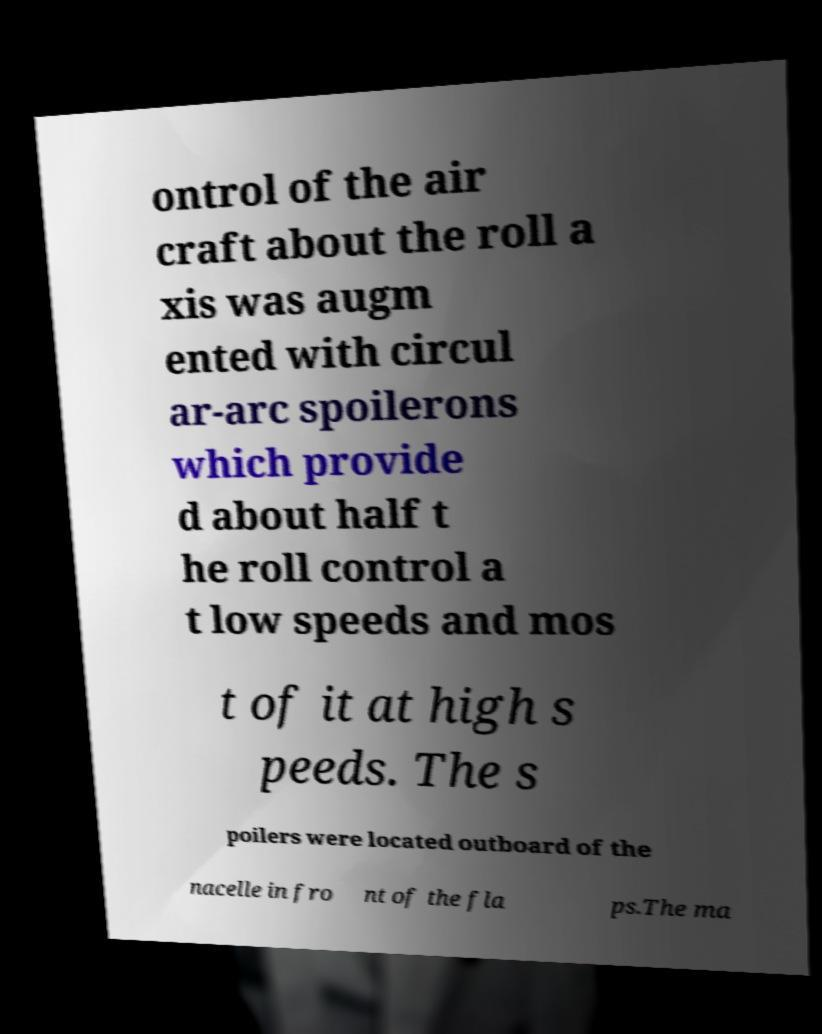What messages or text are displayed in this image? I need them in a readable, typed format. ontrol of the air craft about the roll a xis was augm ented with circul ar-arc spoilerons which provide d about half t he roll control a t low speeds and mos t of it at high s peeds. The s poilers were located outboard of the nacelle in fro nt of the fla ps.The ma 